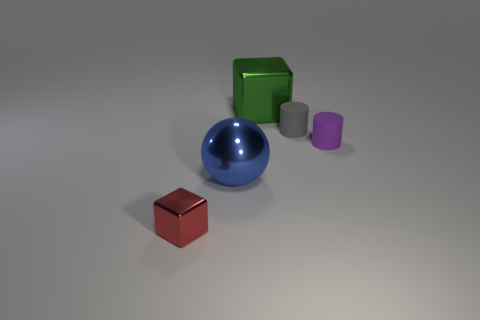Add 5 small gray things. How many objects exist? 10 Subtract all blocks. How many objects are left? 3 Add 3 metallic cubes. How many metallic cubes are left? 5 Add 1 blocks. How many blocks exist? 3 Subtract 0 green spheres. How many objects are left? 5 Subtract all big green shiny blocks. Subtract all big objects. How many objects are left? 2 